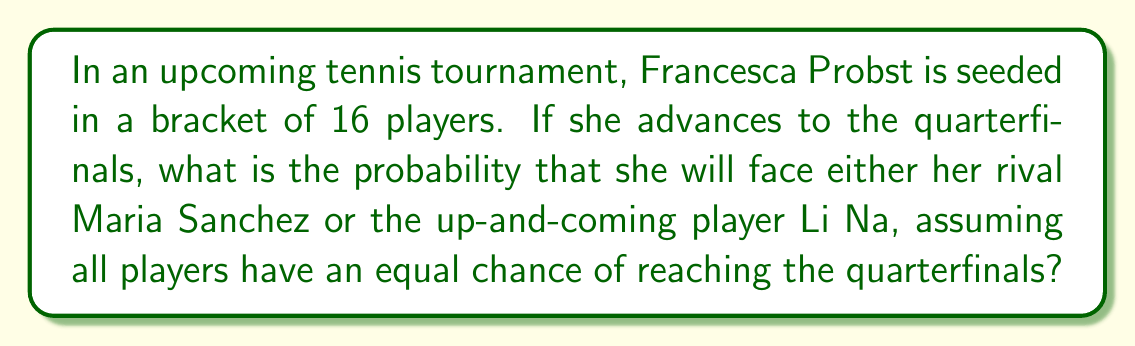Could you help me with this problem? Let's approach this step-by-step:

1) First, we need to understand the structure of the tournament:
   - There are 16 players in total
   - The quarterfinals will have 8 players

2) If Francesca Probst reaches the quarterfinals, there will be 7 other players in this round.

3) Out of these 7 players, we're interested in the probability of facing either Maria Sanchez or Li Na.

4) This is equivalent to calculating the probability that at least one of these two players is among the 7 other quarterfinalists.

5) We can use the complement rule: 
   P(at least one) = 1 - P(neither)

6) The probability of neither Maria Sanchez nor Li Na being in the quarterfinals:
   $$P(\text{neither}) = \frac{\binom{13}{7}}{\binom{15}{7}}$$

   This is because we're choosing 7 players from the 13 players who are not Francesca, Maria, or Li, out of all possible ways to choose 7 from 15.

7) Calculate:
   $$\binom{13}{7} = 1716$$
   $$\binom{15}{7} = 6435$$

8) Therefore:
   $$P(\text{neither}) = \frac{1716}{6435} = \frac{572}{2145} \approx 0.2667$$

9) The probability we're looking for is:
   $$P(\text{at least one}) = 1 - P(\text{neither}) = 1 - \frac{572}{2145} = \frac{1573}{2145} \approx 0.7333$$
Answer: $\frac{1573}{2145}$ 